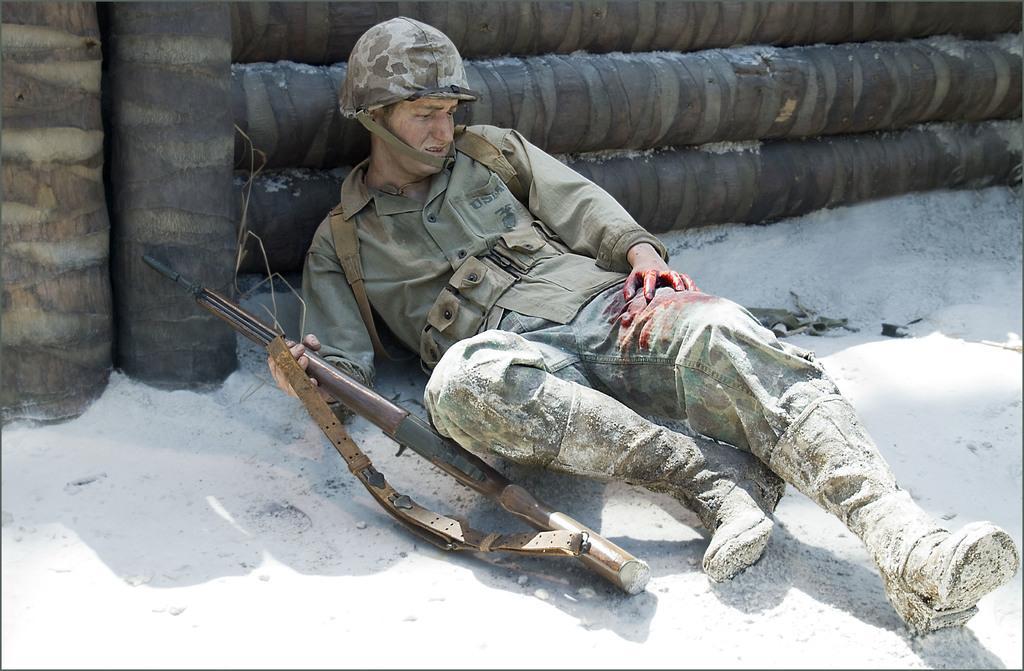Can you describe this image briefly? In this image we can see a person wearing military uniform and a helmet is holding a gun in his hand is lying on the ground. In the background, we can see wood logs. 